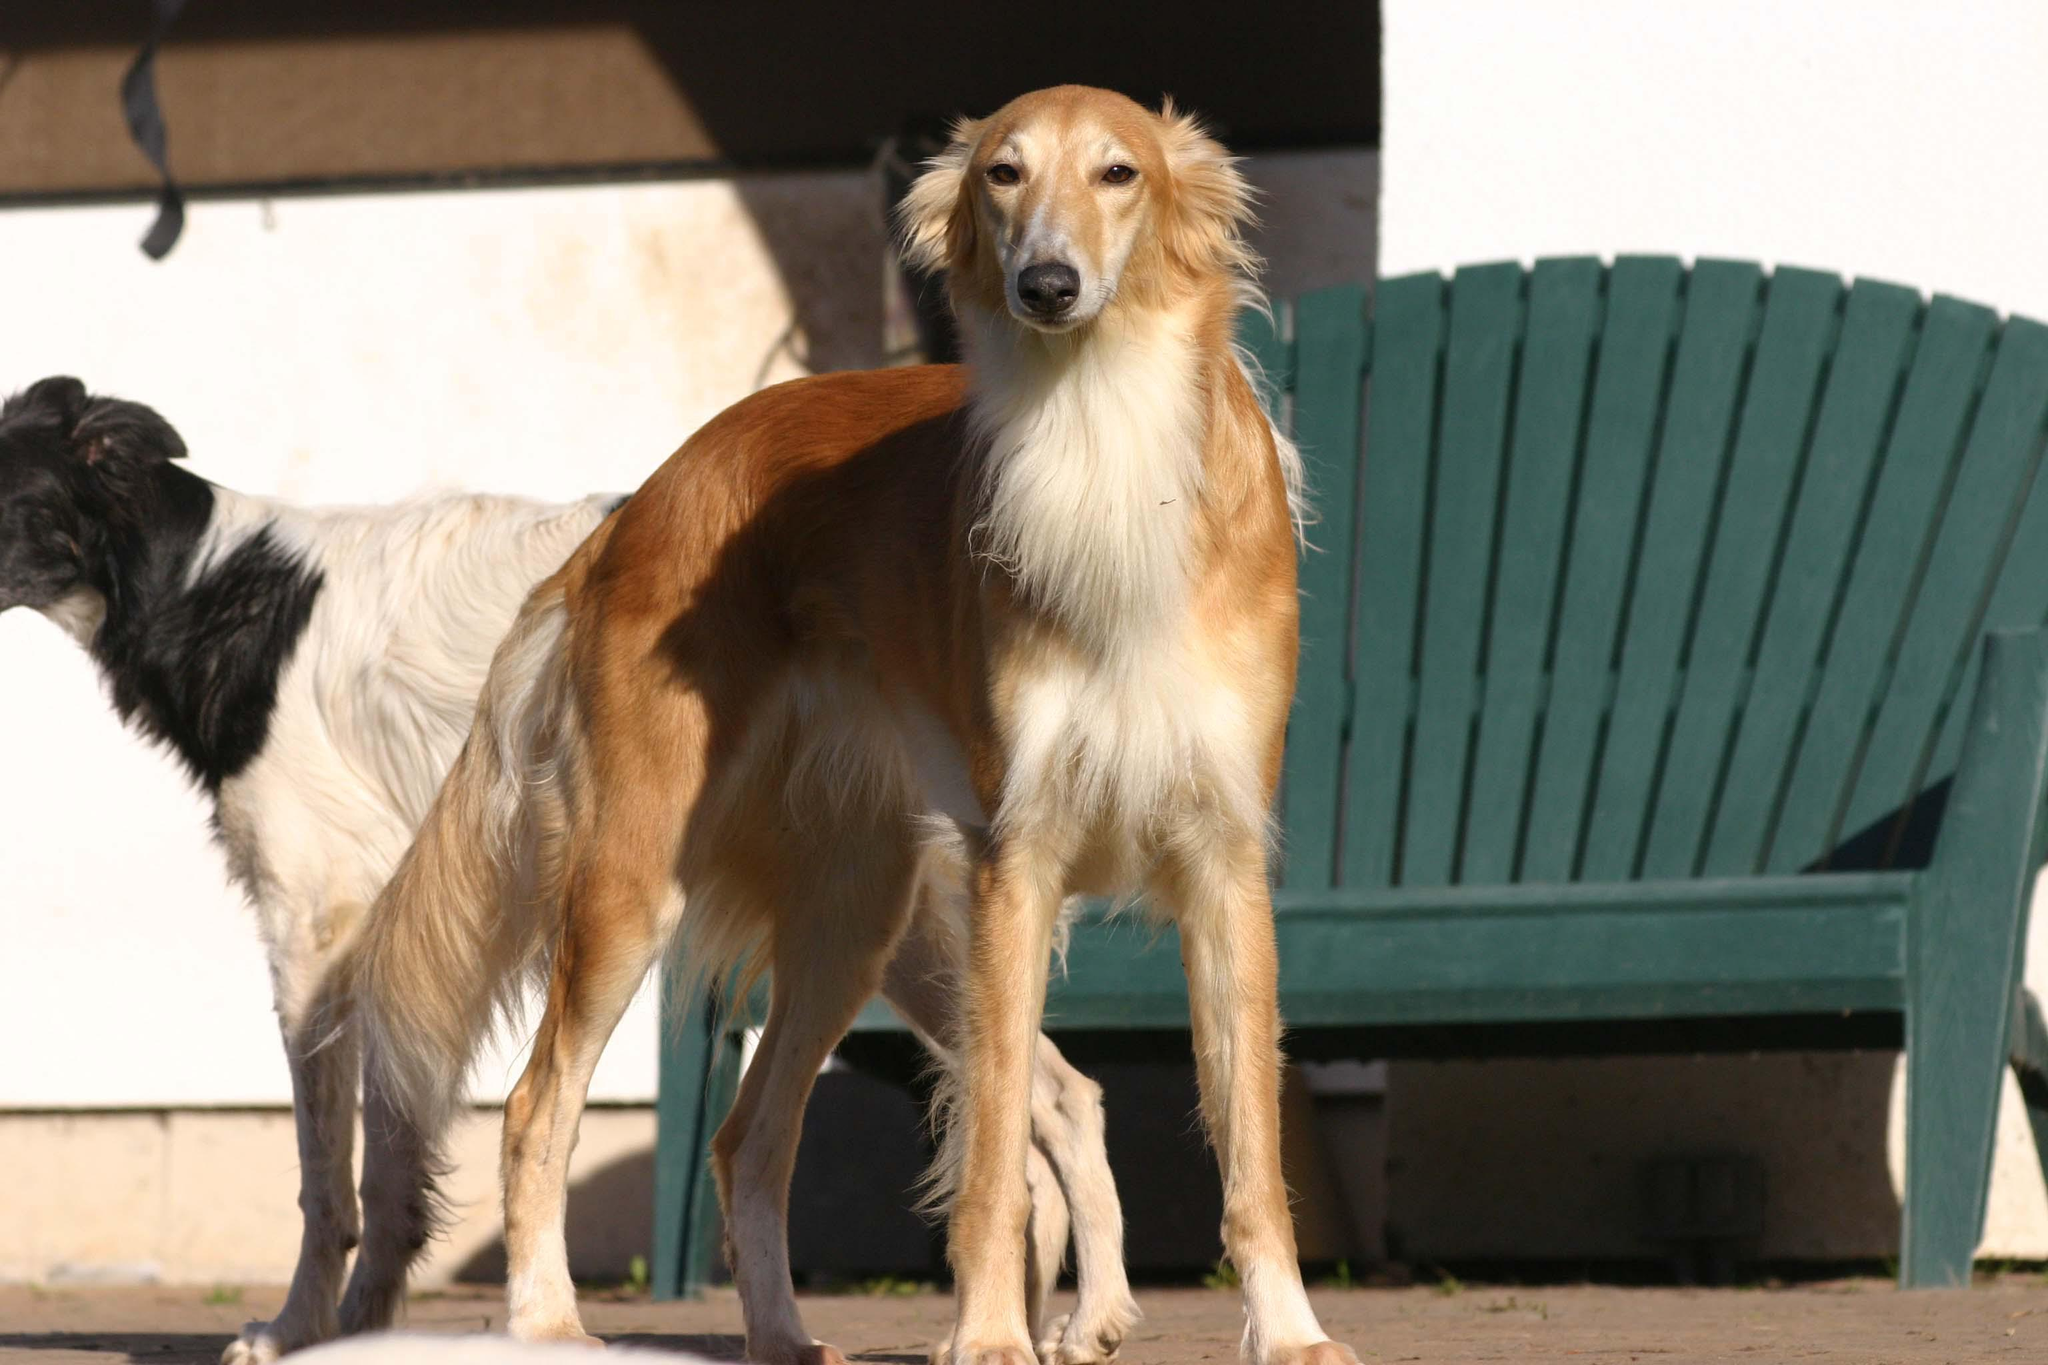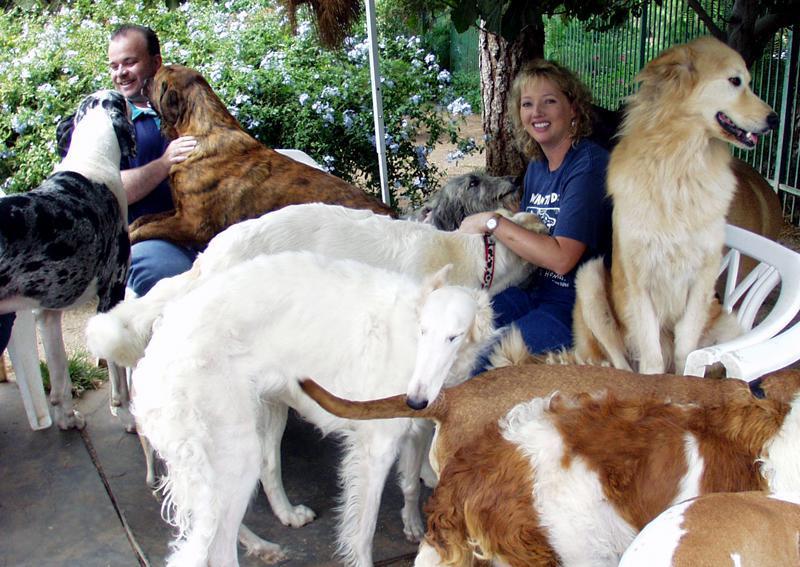The first image is the image on the left, the second image is the image on the right. Analyze the images presented: Is the assertion "An image contains no more than two hound dogs." valid? Answer yes or no. Yes. 